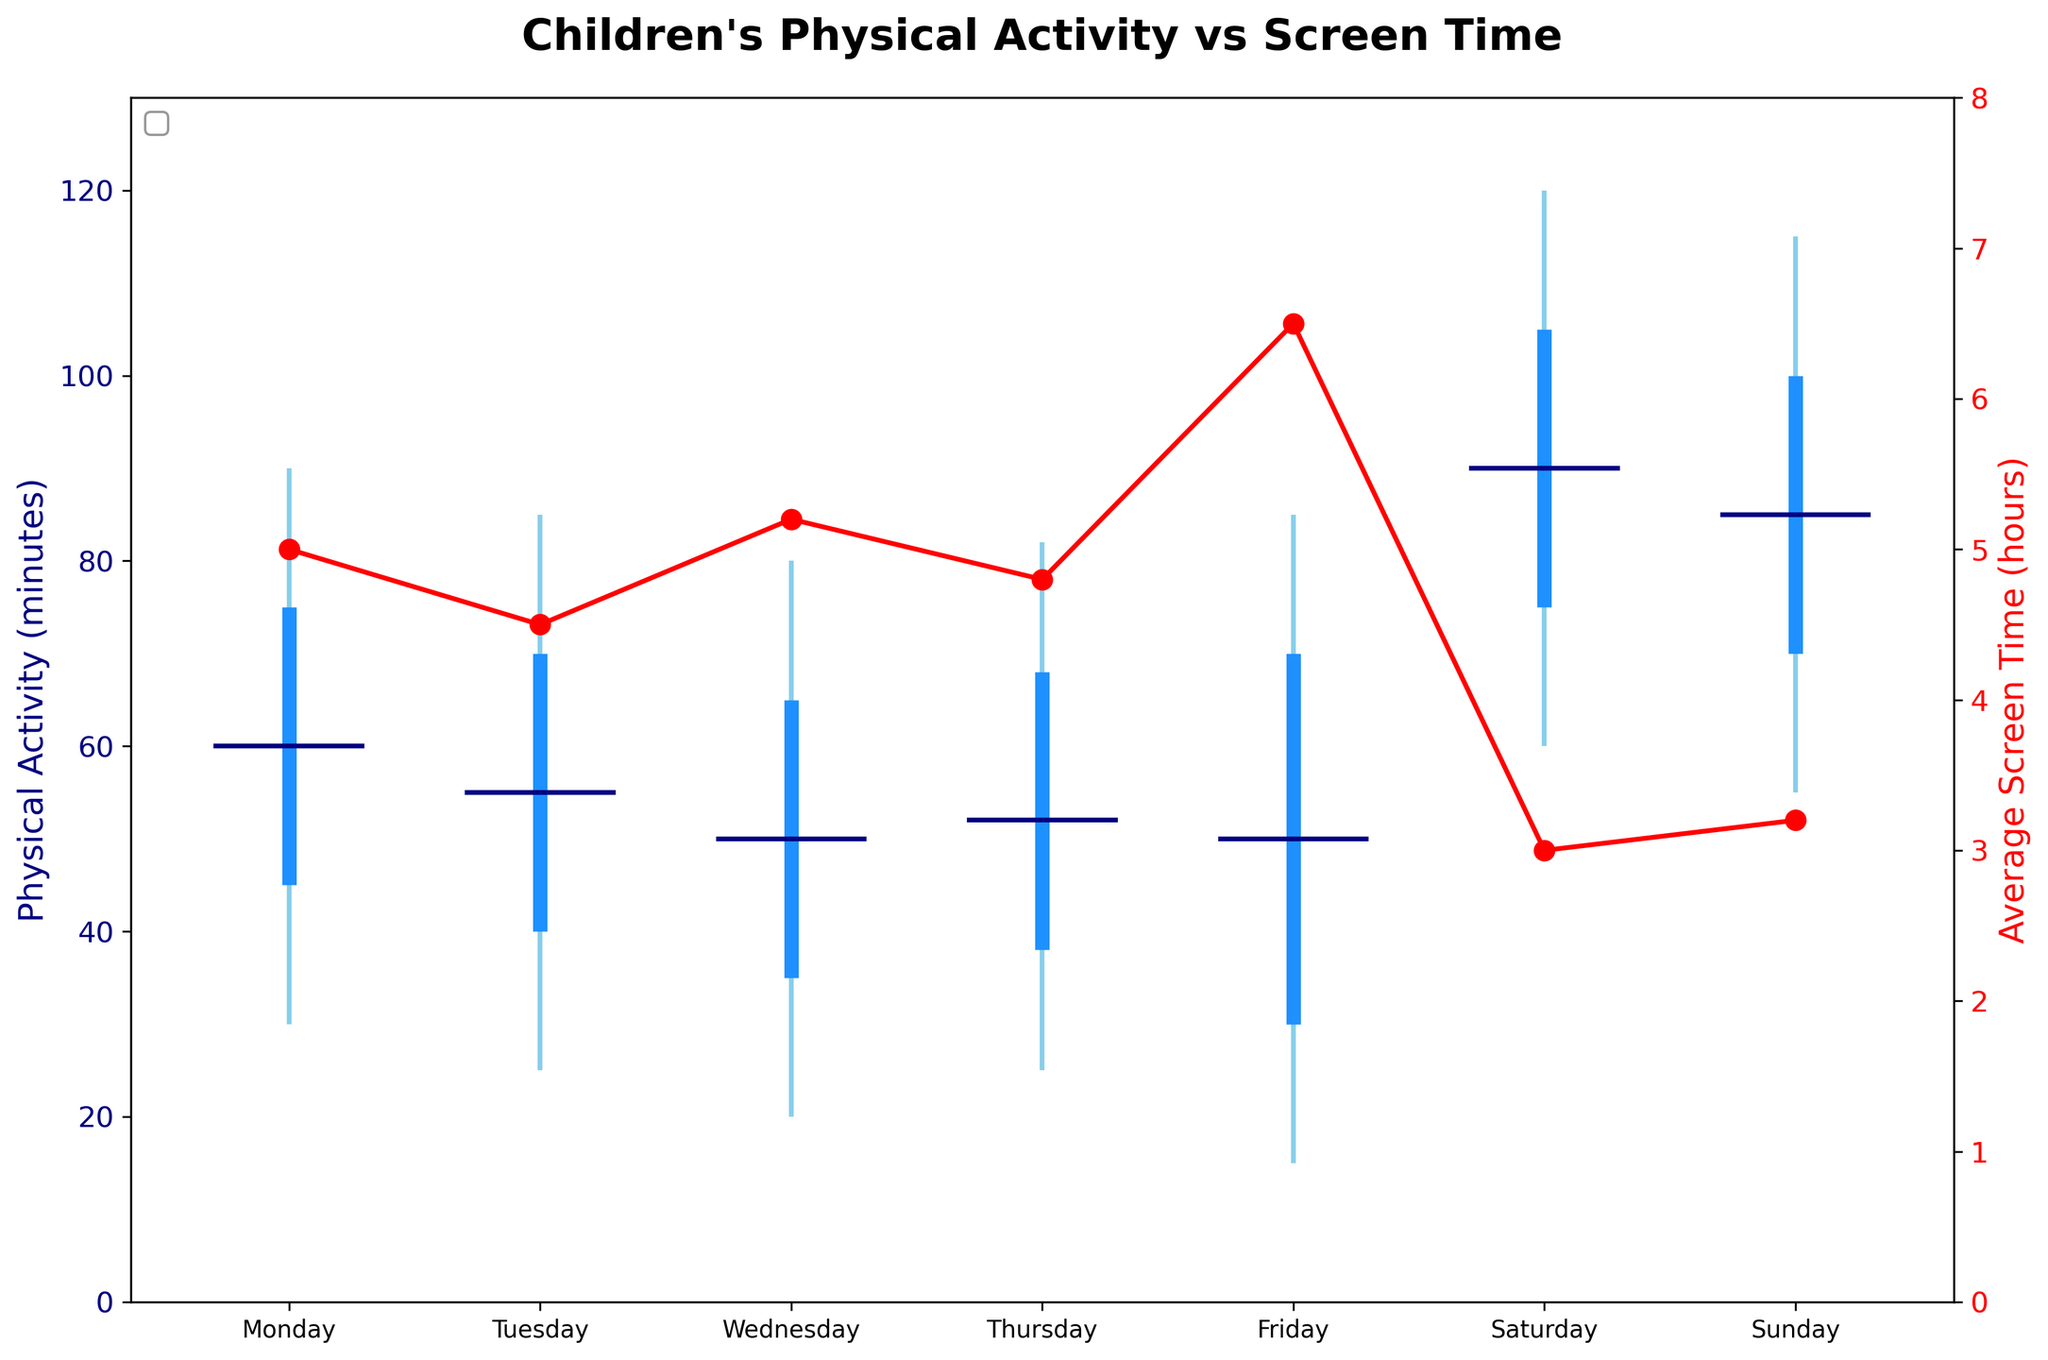What's the title of the figure? The title is located at the top of the figure and summarizes the data being presented.
Answer: Children's Physical Activity vs Screen Time Which day has the highest maximum physical activity level? Maximum physical activity is indicated by the top of the candlestick. The highest max is on Saturday.
Answer: Saturday What is the median value for physical activity on Thursday? Median values for physical activity are represented by the horizontal line inside the candlestick. For Thursday, the median is 52.
Answer: 52 How does the average screen time on Friday compare to Saturday? The red line with markers shows the average screen time. Friday has 6.5 hours, while Saturday has 3 hours. Friday's screen time is higher than Saturday's.
Answer: Friday's is higher What is the range of physical activity on Monday? The range is calculated as the difference between the maximum and minimum values of physical activity. For Monday, it's 90 - 30 = 60.
Answer: 60 minutes Which day shows the lowest minimum physical activity level? Minimum physical activity is shown at the bottom of the candlestick. The lowest minimum is on Friday, with 15 minutes.
Answer: Friday Is there any day where the third quartile of physical activity exceeds 100 minutes? The third quartile is represented by the top part of the thicker blue line segment. For Saturday, the third quartile is 105 minutes, which exceeds 100.
Answer: Yes, Saturday Compare the median physical activity on Tuesday and Thursday. Which day is higher? The median is shown by the horizontal line within the candlestick. Tuesday's median is 55, and Thursday's is 52. Tuesday has a higher median.
Answer: Tuesday Can you determine if there's a trend between screen time and physical activity levels based on this plot? To understand the trend, compare the screen time with physical activity levels on different days. Generally, higher screen time days (e.g., Friday) have lower physical activity, while lower screen time days (e.g., weekend) have higher physical activity.
Answer: Yes, inverse trend What is the interquartile range (IQR) of physical activity on Sunday? The IQR is the difference between the third and first quartiles. For Sunday, the IQR is 100 - 70 = 30.
Answer: 30 minutes 